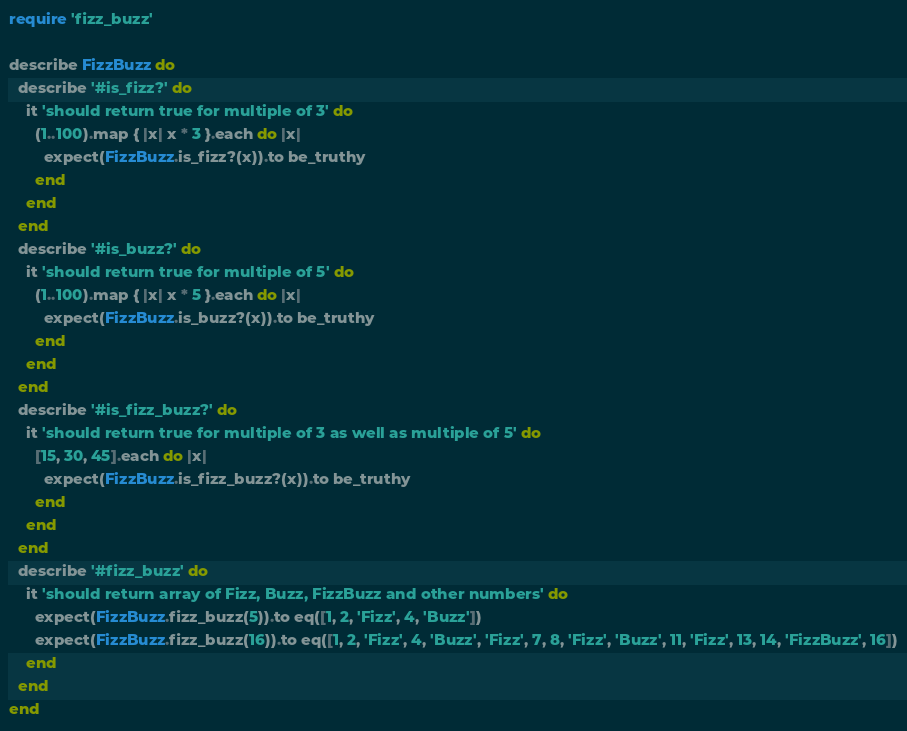Convert code to text. <code><loc_0><loc_0><loc_500><loc_500><_Ruby_>require 'fizz_buzz'

describe FizzBuzz do
  describe '#is_fizz?' do
    it 'should return true for multiple of 3' do
      (1..100).map { |x| x * 3 }.each do |x|
        expect(FizzBuzz.is_fizz?(x)).to be_truthy
      end
    end
  end
  describe '#is_buzz?' do
    it 'should return true for multiple of 5' do
      (1..100).map { |x| x * 5 }.each do |x|
        expect(FizzBuzz.is_buzz?(x)).to be_truthy
      end
    end
  end
  describe '#is_fizz_buzz?' do
    it 'should return true for multiple of 3 as well as multiple of 5' do
      [15, 30, 45].each do |x|
        expect(FizzBuzz.is_fizz_buzz?(x)).to be_truthy
      end
    end
  end
  describe '#fizz_buzz' do
    it 'should return array of Fizz, Buzz, FizzBuzz and other numbers' do
      expect(FizzBuzz.fizz_buzz(5)).to eq([1, 2, 'Fizz', 4, 'Buzz'])
      expect(FizzBuzz.fizz_buzz(16)).to eq([1, 2, 'Fizz', 4, 'Buzz', 'Fizz', 7, 8, 'Fizz', 'Buzz', 11, 'Fizz', 13, 14, 'FizzBuzz', 16])
    end
  end
end
</code> 